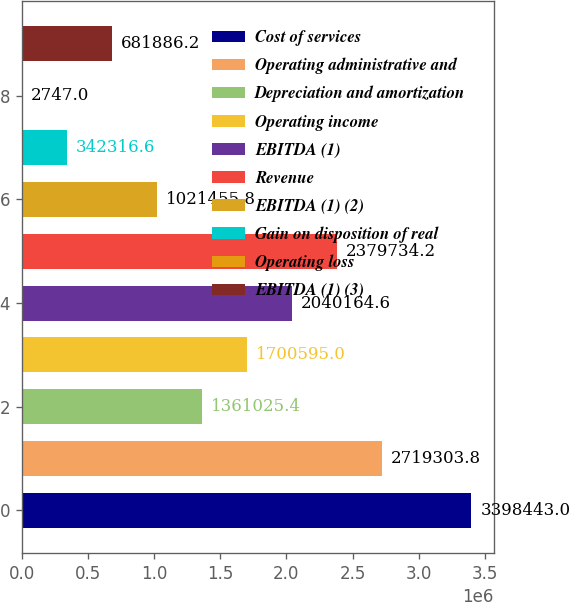Convert chart to OTSL. <chart><loc_0><loc_0><loc_500><loc_500><bar_chart><fcel>Cost of services<fcel>Operating administrative and<fcel>Depreciation and amortization<fcel>Operating income<fcel>EBITDA (1)<fcel>Revenue<fcel>EBITDA (1) (2)<fcel>Gain on disposition of real<fcel>Operating loss<fcel>EBITDA (1) (3)<nl><fcel>3.39844e+06<fcel>2.7193e+06<fcel>1.36103e+06<fcel>1.7006e+06<fcel>2.04016e+06<fcel>2.37973e+06<fcel>1.02146e+06<fcel>342317<fcel>2747<fcel>681886<nl></chart> 